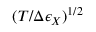Convert formula to latex. <formula><loc_0><loc_0><loc_500><loc_500>( T / \Delta \epsilon _ { X } ) ^ { 1 / 2 }</formula> 